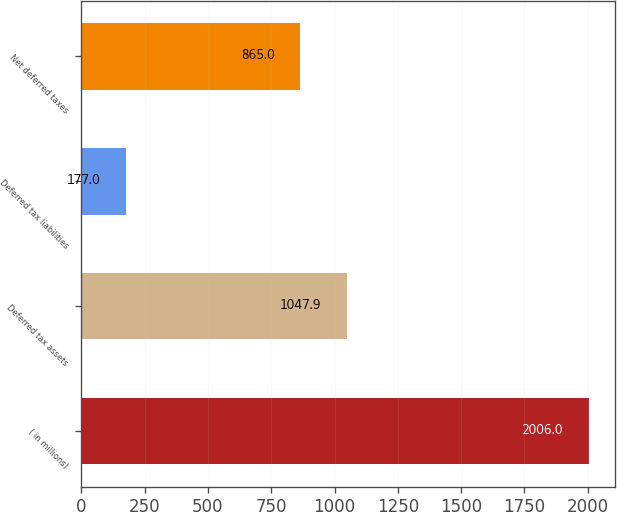Convert chart. <chart><loc_0><loc_0><loc_500><loc_500><bar_chart><fcel>( in millions)<fcel>Deferred tax assets<fcel>Deferred tax liabilities<fcel>Net deferred taxes<nl><fcel>2006<fcel>1047.9<fcel>177<fcel>865<nl></chart> 